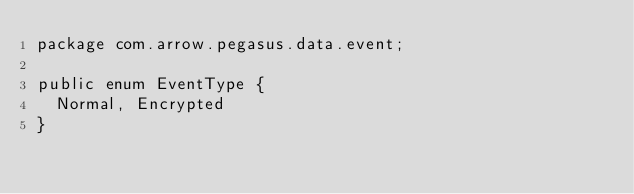Convert code to text. <code><loc_0><loc_0><loc_500><loc_500><_Java_>package com.arrow.pegasus.data.event;

public enum EventType {
	Normal, Encrypted
}</code> 